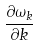Convert formula to latex. <formula><loc_0><loc_0><loc_500><loc_500>\frac { \partial \omega _ { k } } { \partial k }</formula> 